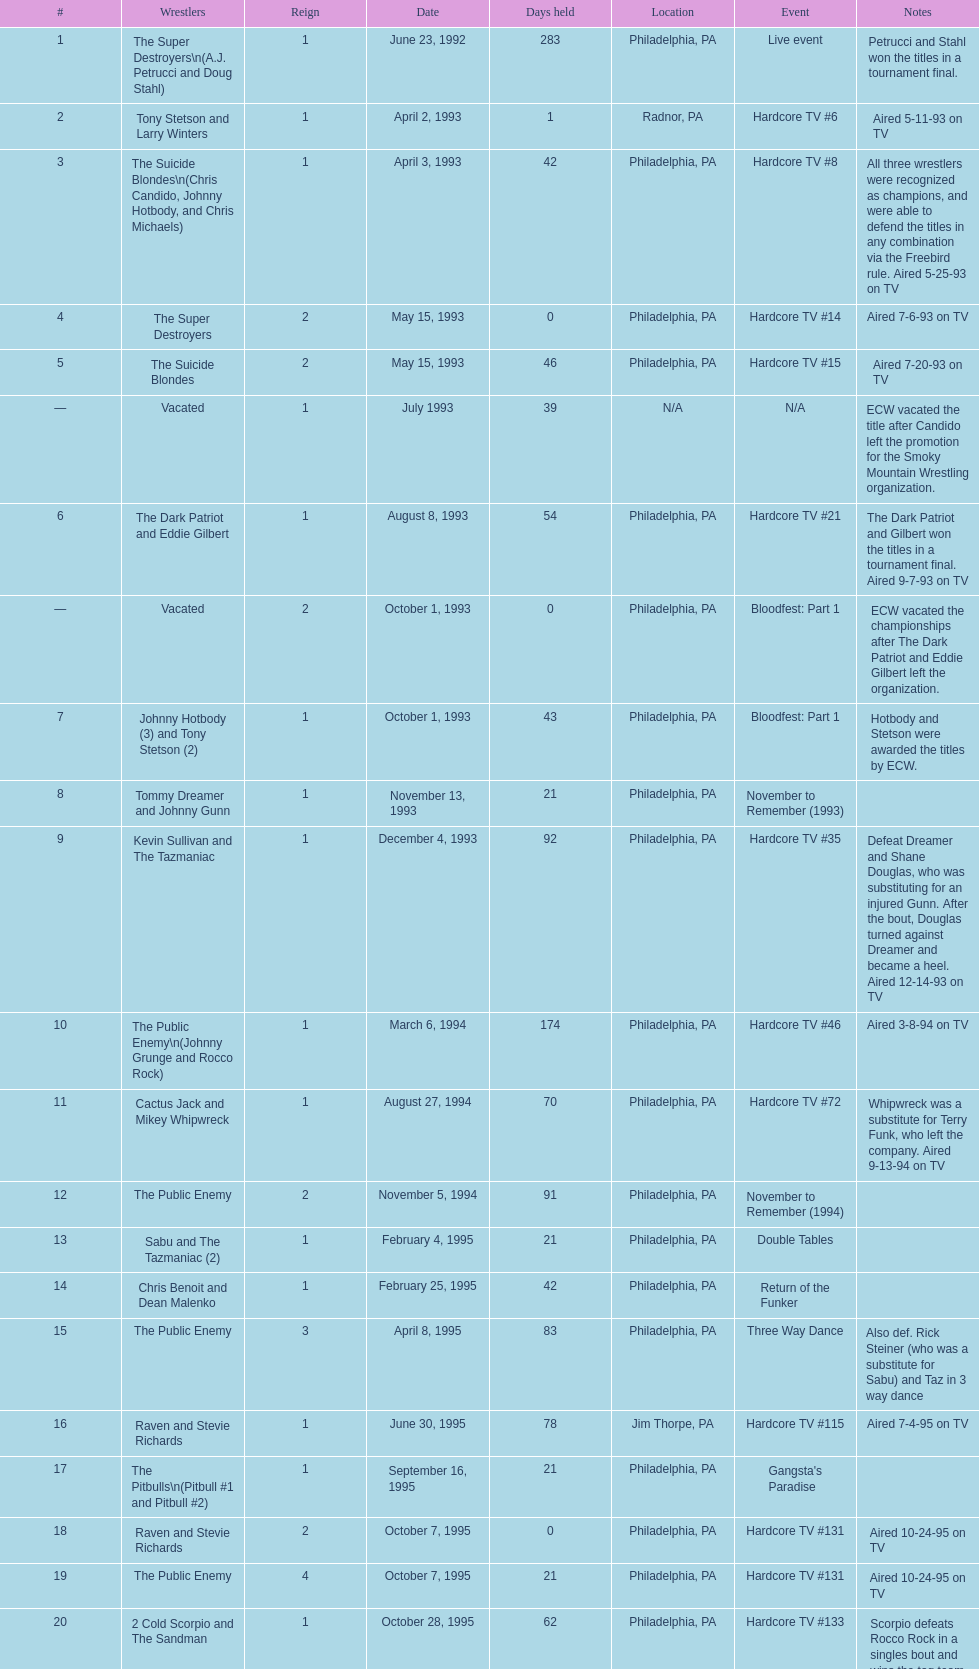Which was the only team to win by forfeit? The Dudley Boyz. 